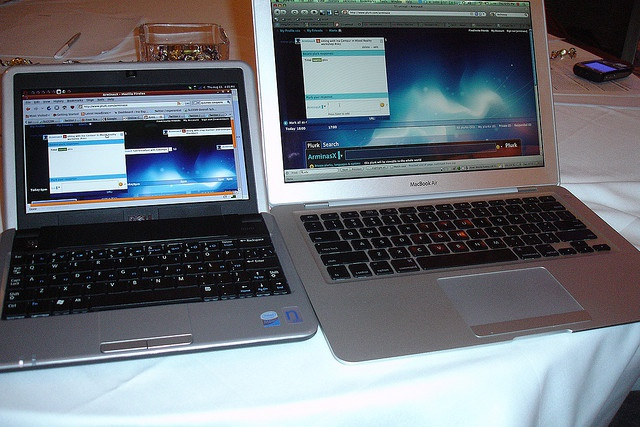Describe the objects in this image and their specific colors. I can see laptop in maroon, gray, black, darkgray, and white tones, laptop in maroon, black, gray, lightblue, and darkgray tones, and cell phone in maroon, black, blue, and navy tones in this image. 